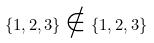Convert formula to latex. <formula><loc_0><loc_0><loc_500><loc_500>\{ 1 , 2 , 3 \} \notin \{ 1 , 2 , 3 \}</formula> 